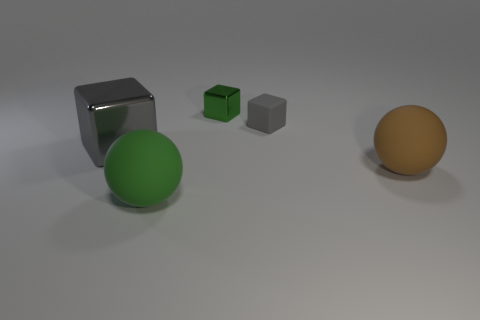There is another large block that is the same color as the rubber block; what is its material?
Offer a terse response. Metal. There is a gray metallic object that is the same size as the green rubber object; what is its shape?
Provide a short and direct response. Cube. Do the small green block and the green ball that is in front of the small green object have the same material?
Offer a terse response. No. There is a green thing in front of the rubber block; what is its material?
Provide a succinct answer. Rubber. There is a object that is both behind the gray shiny object and to the left of the small gray matte thing; what shape is it?
Offer a terse response. Cube. What material is the small green thing?
Make the answer very short. Metal. How many cylinders are large blue rubber things or big objects?
Your answer should be compact. 0. Does the big gray object have the same material as the brown sphere?
Provide a short and direct response. No. What size is the green shiny thing that is the same shape as the large gray shiny object?
Your answer should be compact. Small. What material is the object that is both in front of the green shiny object and behind the large gray metal cube?
Ensure brevity in your answer.  Rubber. 